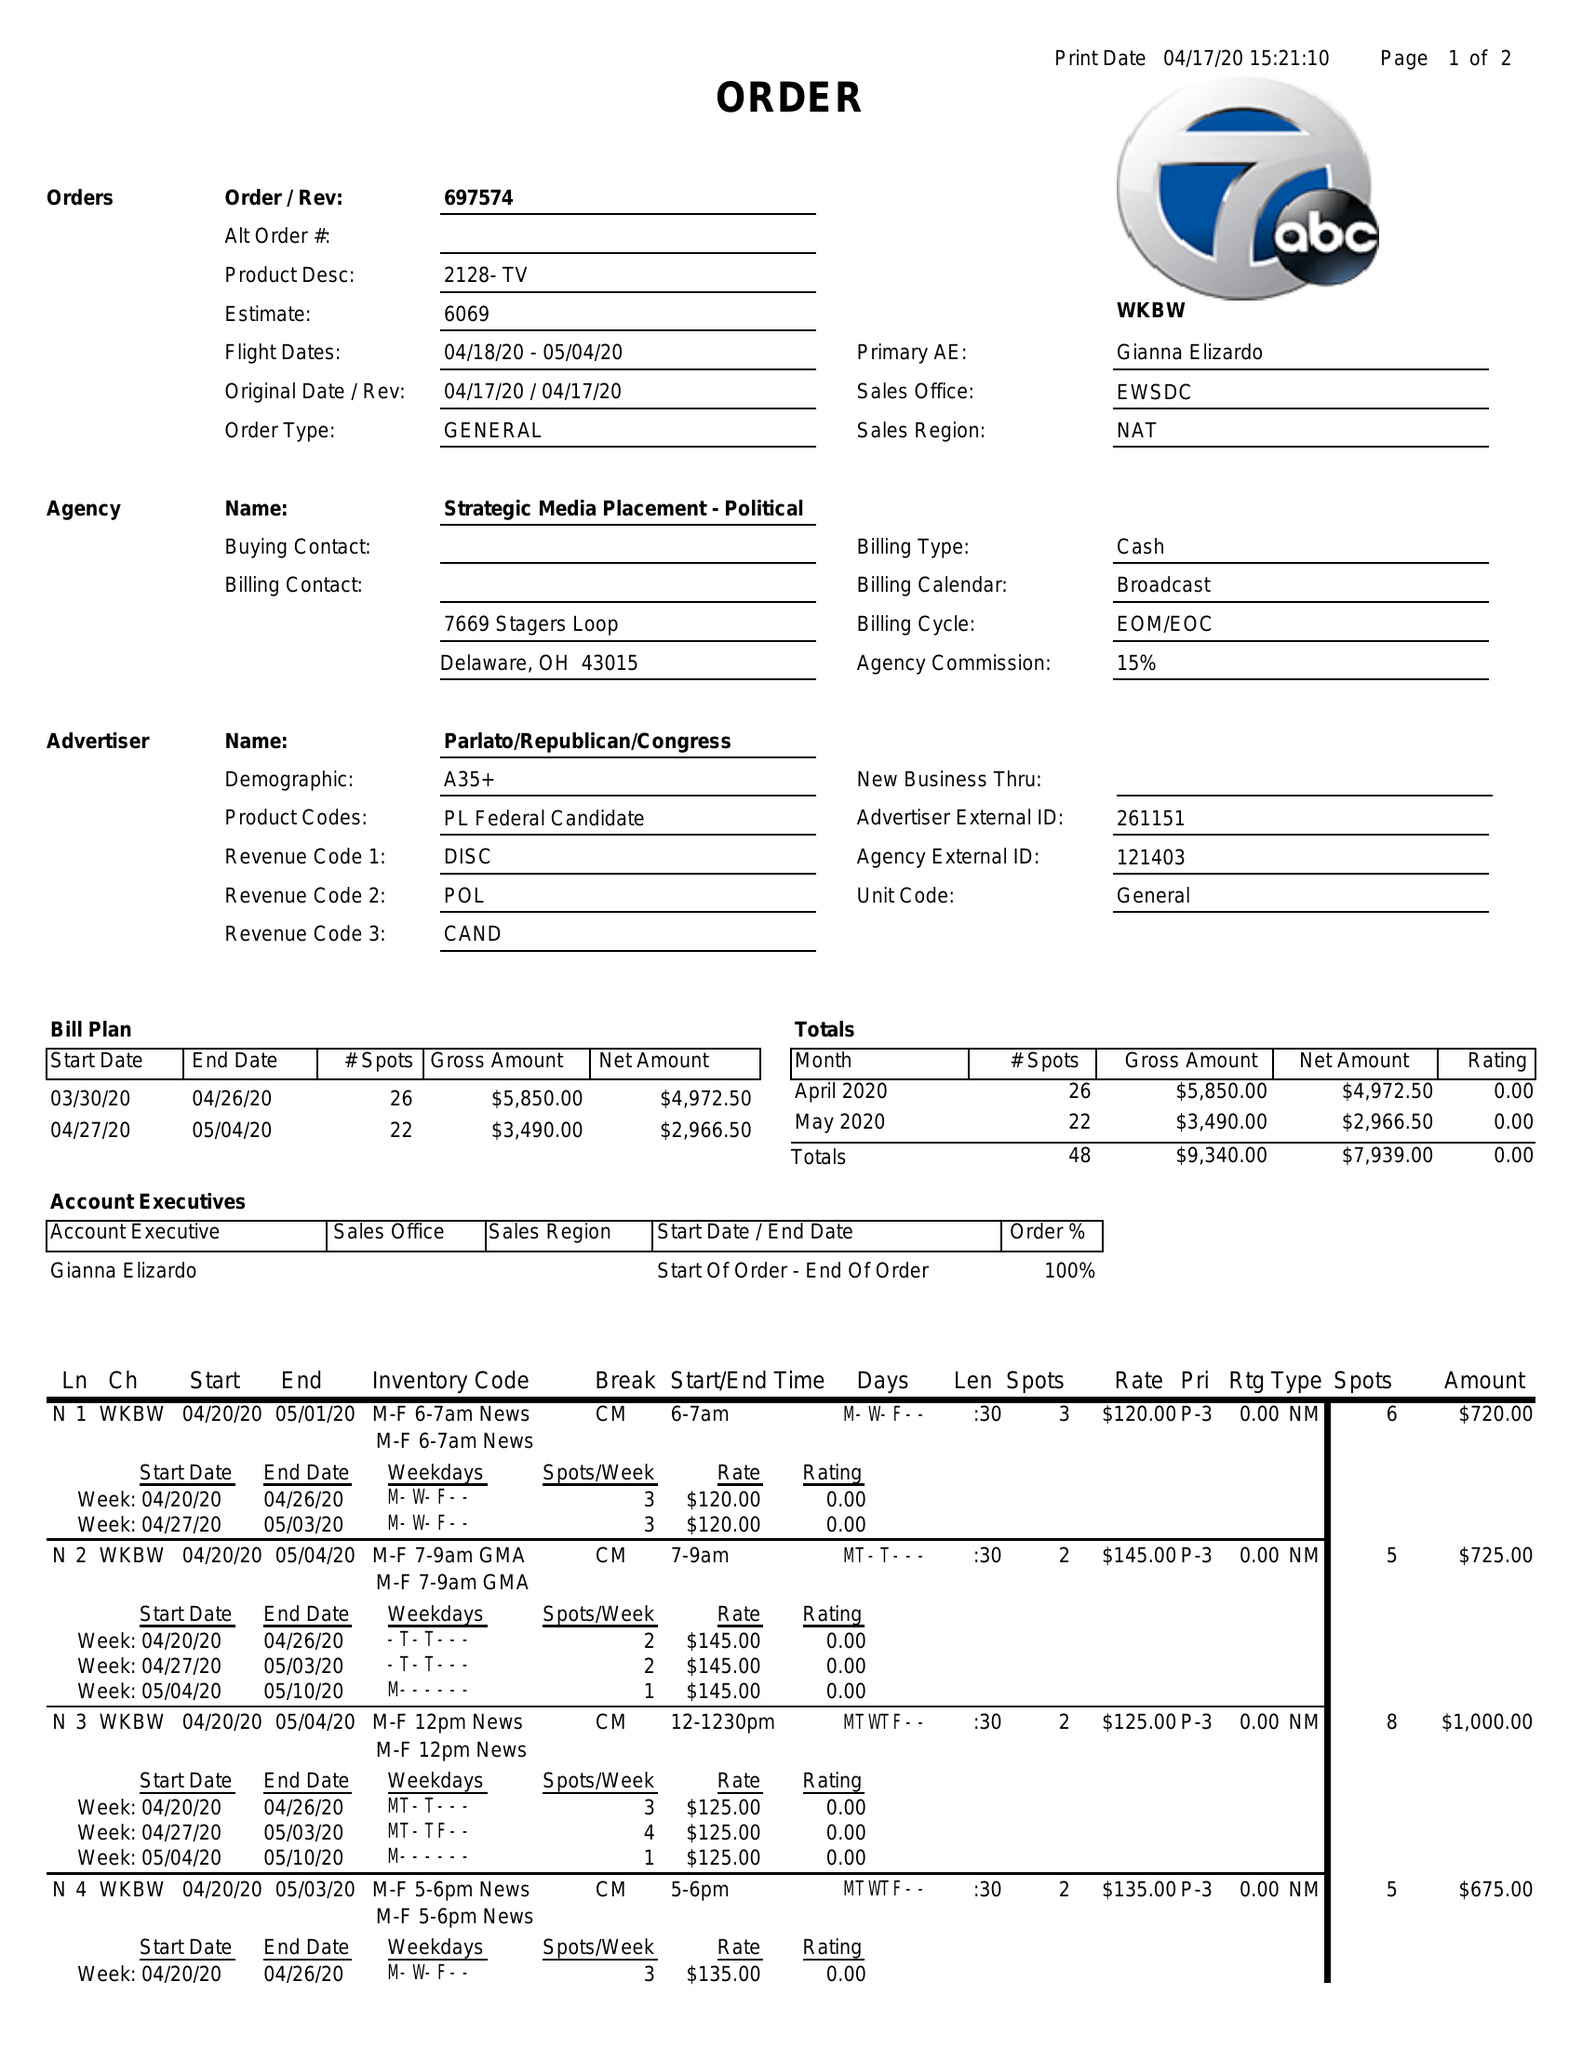What is the value for the contract_num?
Answer the question using a single word or phrase. 697574 